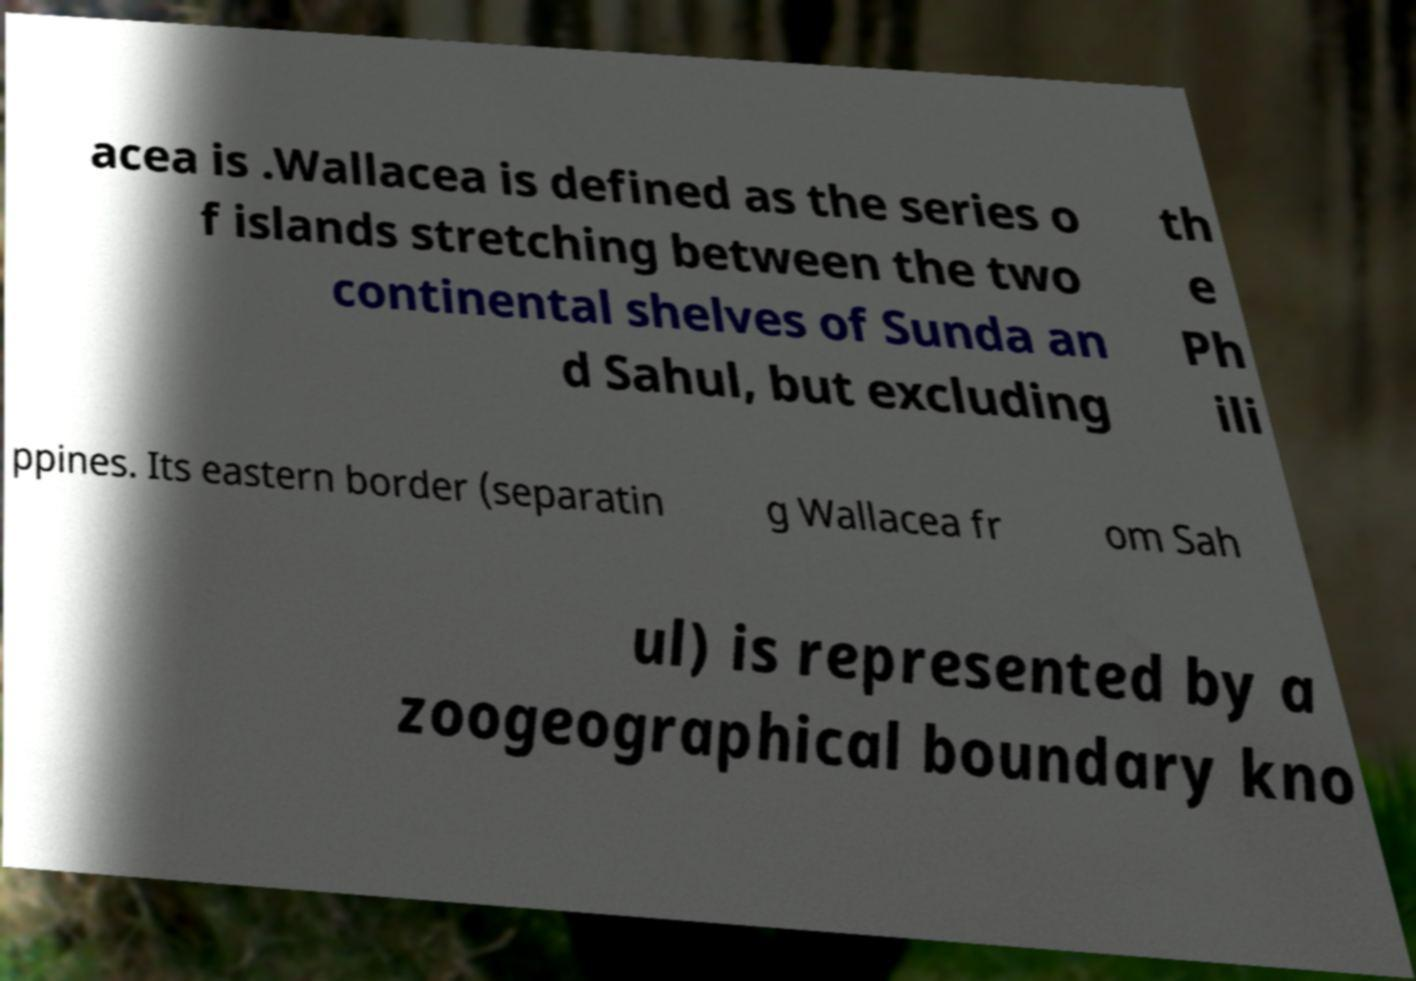There's text embedded in this image that I need extracted. Can you transcribe it verbatim? acea is .Wallacea is defined as the series o f islands stretching between the two continental shelves of Sunda an d Sahul, but excluding th e Ph ili ppines. Its eastern border (separatin g Wallacea fr om Sah ul) is represented by a zoogeographical boundary kno 